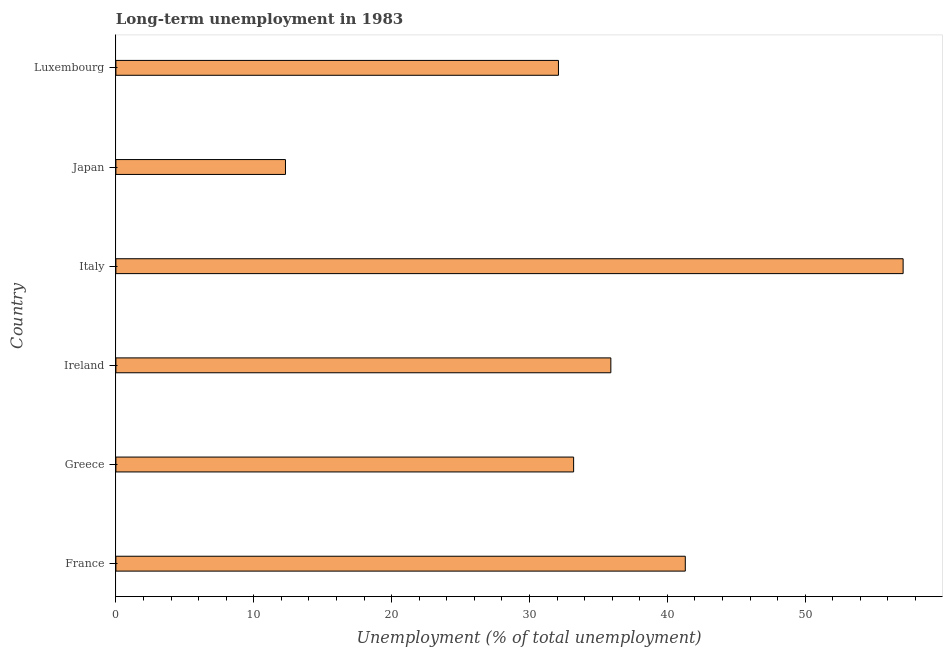Does the graph contain any zero values?
Make the answer very short. No. What is the title of the graph?
Ensure brevity in your answer.  Long-term unemployment in 1983. What is the label or title of the X-axis?
Offer a terse response. Unemployment (% of total unemployment). What is the long-term unemployment in Italy?
Offer a very short reply. 57.1. Across all countries, what is the maximum long-term unemployment?
Your response must be concise. 57.1. Across all countries, what is the minimum long-term unemployment?
Offer a very short reply. 12.3. In which country was the long-term unemployment maximum?
Keep it short and to the point. Italy. In which country was the long-term unemployment minimum?
Provide a short and direct response. Japan. What is the sum of the long-term unemployment?
Offer a terse response. 211.9. What is the difference between the long-term unemployment in France and Luxembourg?
Your answer should be very brief. 9.2. What is the average long-term unemployment per country?
Make the answer very short. 35.32. What is the median long-term unemployment?
Provide a succinct answer. 34.55. In how many countries, is the long-term unemployment greater than 14 %?
Provide a short and direct response. 5. What is the ratio of the long-term unemployment in Ireland to that in Luxembourg?
Offer a terse response. 1.12. Is the long-term unemployment in Japan less than that in Luxembourg?
Offer a very short reply. Yes. Is the sum of the long-term unemployment in Greece and Italy greater than the maximum long-term unemployment across all countries?
Provide a short and direct response. Yes. What is the difference between the highest and the lowest long-term unemployment?
Offer a very short reply. 44.8. In how many countries, is the long-term unemployment greater than the average long-term unemployment taken over all countries?
Ensure brevity in your answer.  3. Are all the bars in the graph horizontal?
Give a very brief answer. Yes. Are the values on the major ticks of X-axis written in scientific E-notation?
Make the answer very short. No. What is the Unemployment (% of total unemployment) of France?
Offer a terse response. 41.3. What is the Unemployment (% of total unemployment) of Greece?
Offer a terse response. 33.2. What is the Unemployment (% of total unemployment) in Ireland?
Your response must be concise. 35.9. What is the Unemployment (% of total unemployment) of Italy?
Provide a succinct answer. 57.1. What is the Unemployment (% of total unemployment) of Japan?
Your response must be concise. 12.3. What is the Unemployment (% of total unemployment) in Luxembourg?
Your answer should be compact. 32.1. What is the difference between the Unemployment (% of total unemployment) in France and Ireland?
Your response must be concise. 5.4. What is the difference between the Unemployment (% of total unemployment) in France and Italy?
Offer a very short reply. -15.8. What is the difference between the Unemployment (% of total unemployment) in France and Japan?
Your answer should be very brief. 29. What is the difference between the Unemployment (% of total unemployment) in France and Luxembourg?
Keep it short and to the point. 9.2. What is the difference between the Unemployment (% of total unemployment) in Greece and Ireland?
Your answer should be very brief. -2.7. What is the difference between the Unemployment (% of total unemployment) in Greece and Italy?
Keep it short and to the point. -23.9. What is the difference between the Unemployment (% of total unemployment) in Greece and Japan?
Keep it short and to the point. 20.9. What is the difference between the Unemployment (% of total unemployment) in Ireland and Italy?
Ensure brevity in your answer.  -21.2. What is the difference between the Unemployment (% of total unemployment) in Ireland and Japan?
Provide a short and direct response. 23.6. What is the difference between the Unemployment (% of total unemployment) in Italy and Japan?
Offer a very short reply. 44.8. What is the difference between the Unemployment (% of total unemployment) in Italy and Luxembourg?
Ensure brevity in your answer.  25. What is the difference between the Unemployment (% of total unemployment) in Japan and Luxembourg?
Offer a very short reply. -19.8. What is the ratio of the Unemployment (% of total unemployment) in France to that in Greece?
Provide a short and direct response. 1.24. What is the ratio of the Unemployment (% of total unemployment) in France to that in Ireland?
Provide a succinct answer. 1.15. What is the ratio of the Unemployment (% of total unemployment) in France to that in Italy?
Offer a terse response. 0.72. What is the ratio of the Unemployment (% of total unemployment) in France to that in Japan?
Offer a terse response. 3.36. What is the ratio of the Unemployment (% of total unemployment) in France to that in Luxembourg?
Your answer should be compact. 1.29. What is the ratio of the Unemployment (% of total unemployment) in Greece to that in Ireland?
Provide a succinct answer. 0.93. What is the ratio of the Unemployment (% of total unemployment) in Greece to that in Italy?
Your answer should be compact. 0.58. What is the ratio of the Unemployment (% of total unemployment) in Greece to that in Japan?
Give a very brief answer. 2.7. What is the ratio of the Unemployment (% of total unemployment) in Greece to that in Luxembourg?
Provide a short and direct response. 1.03. What is the ratio of the Unemployment (% of total unemployment) in Ireland to that in Italy?
Provide a succinct answer. 0.63. What is the ratio of the Unemployment (% of total unemployment) in Ireland to that in Japan?
Keep it short and to the point. 2.92. What is the ratio of the Unemployment (% of total unemployment) in Ireland to that in Luxembourg?
Ensure brevity in your answer.  1.12. What is the ratio of the Unemployment (% of total unemployment) in Italy to that in Japan?
Keep it short and to the point. 4.64. What is the ratio of the Unemployment (% of total unemployment) in Italy to that in Luxembourg?
Offer a terse response. 1.78. What is the ratio of the Unemployment (% of total unemployment) in Japan to that in Luxembourg?
Keep it short and to the point. 0.38. 